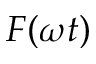Convert formula to latex. <formula><loc_0><loc_0><loc_500><loc_500>F ( \omega t )</formula> 